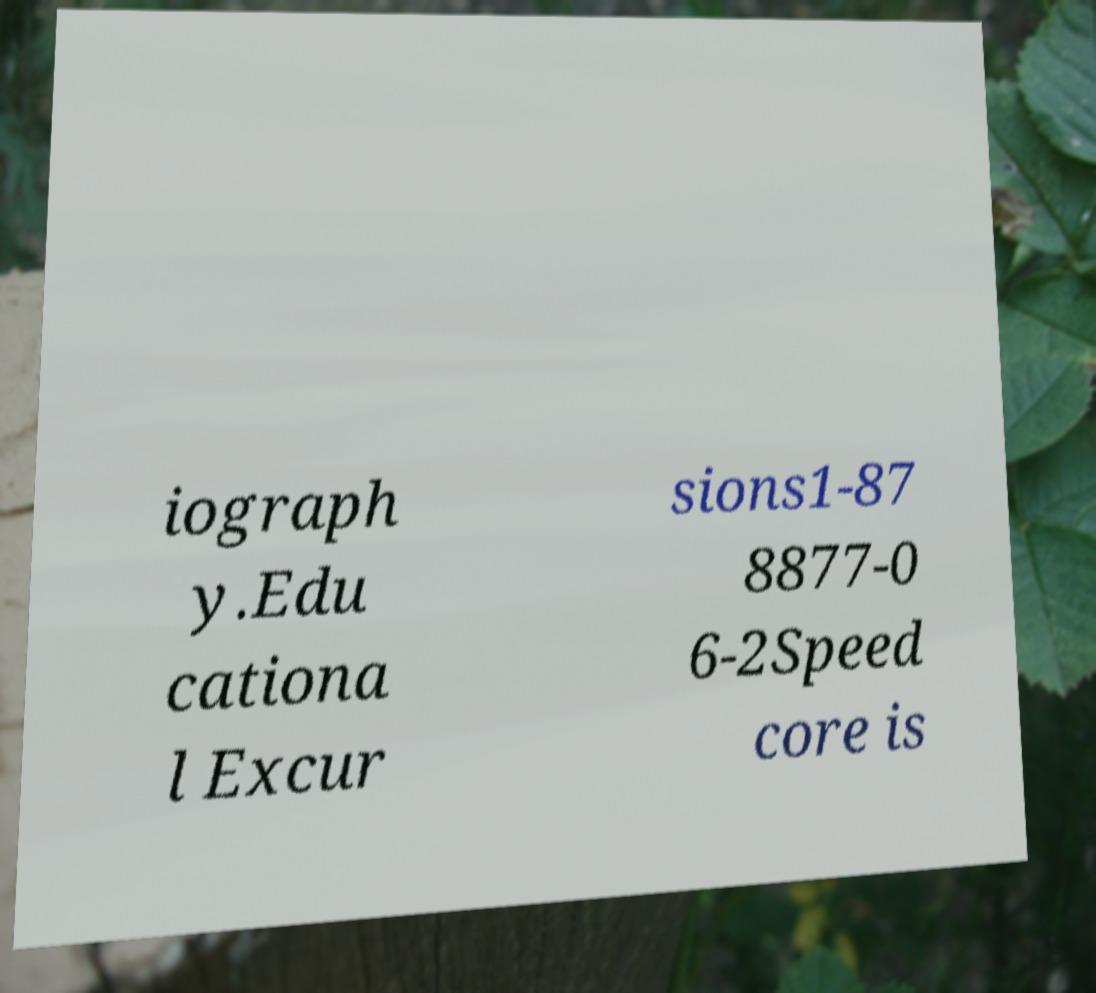Please identify and transcribe the text found in this image. iograph y.Edu cationa l Excur sions1-87 8877-0 6-2Speed core is 